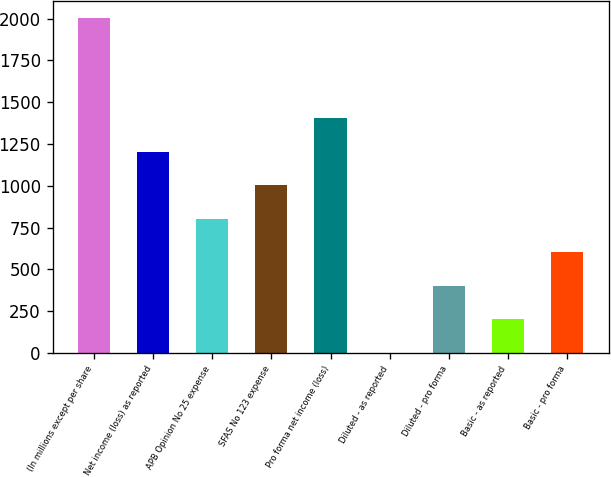Convert chart to OTSL. <chart><loc_0><loc_0><loc_500><loc_500><bar_chart><fcel>(In millions except per share<fcel>Net income (loss) as reported<fcel>APB Opinion No 25 expense<fcel>SFAS No 123 expense<fcel>Pro forma net income (loss)<fcel>Diluted - as reported<fcel>Diluted - pro forma<fcel>Basic - as reported<fcel>Basic - pro forma<nl><fcel>2005<fcel>1203.23<fcel>802.33<fcel>1002.78<fcel>1403.68<fcel>0.53<fcel>401.43<fcel>200.98<fcel>601.88<nl></chart> 